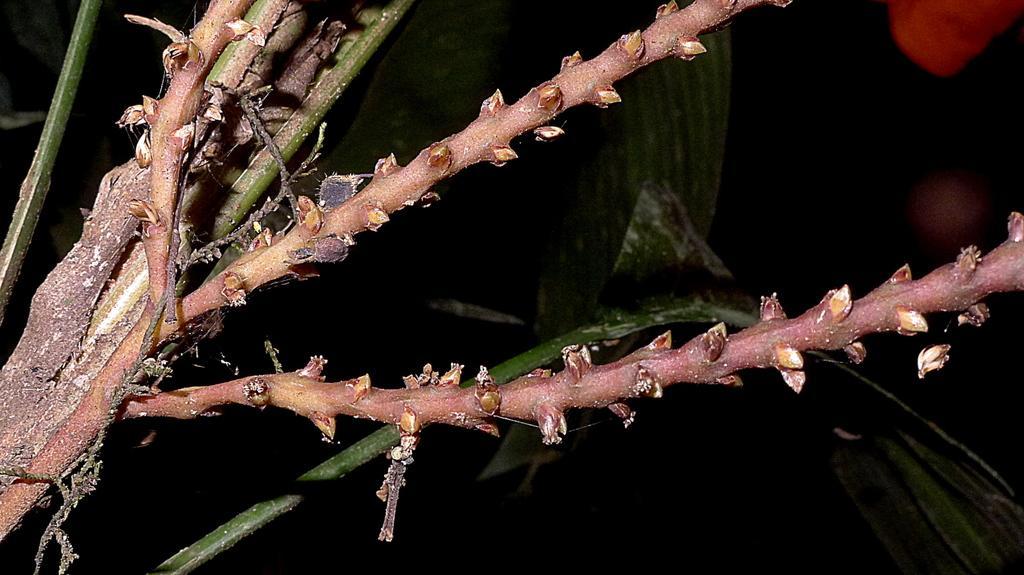In one or two sentences, can you explain what this image depicts? In the picture there is a stem present. 